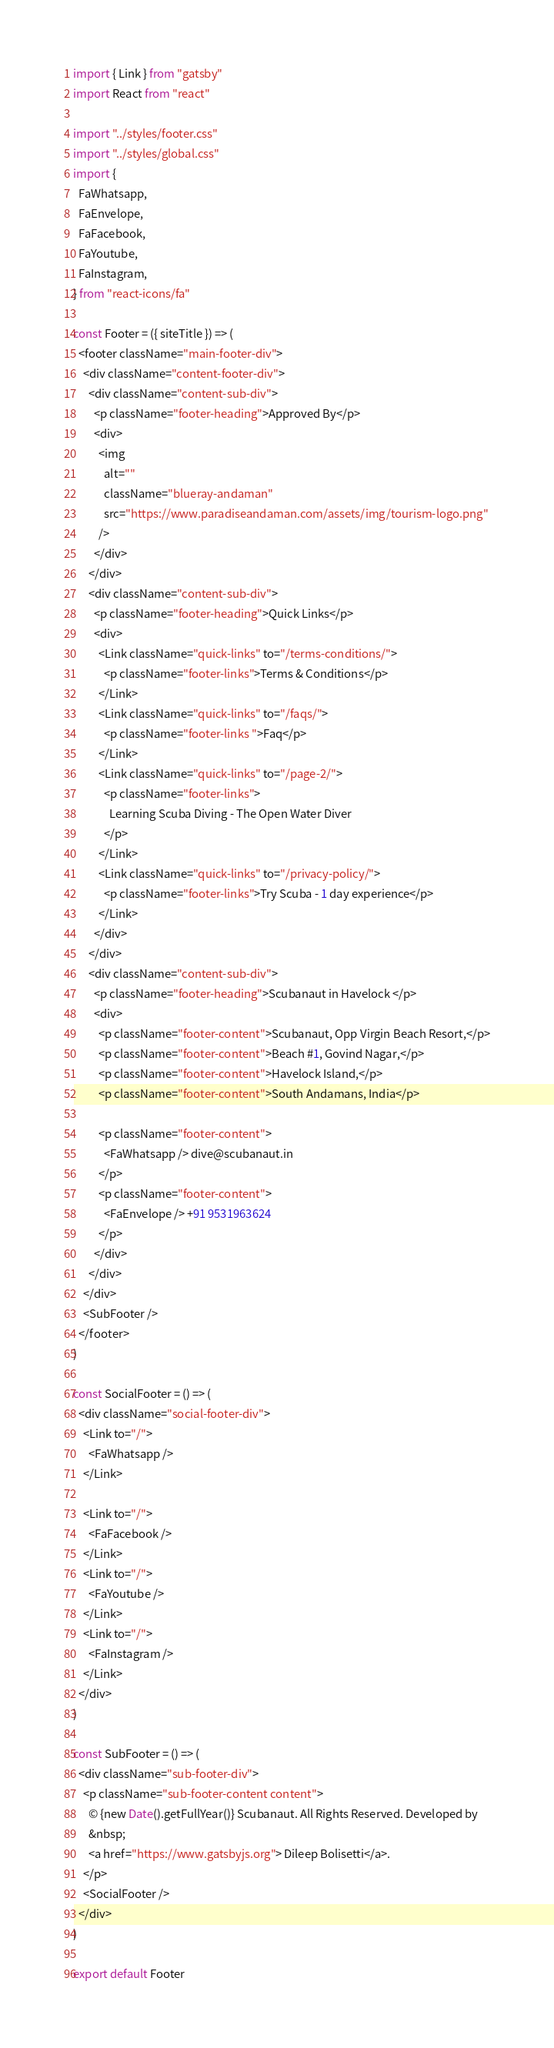<code> <loc_0><loc_0><loc_500><loc_500><_JavaScript_>import { Link } from "gatsby"
import React from "react"

import "../styles/footer.css"
import "../styles/global.css"
import {
  FaWhatsapp,
  FaEnvelope,
  FaFacebook,
  FaYoutube,
  FaInstagram,
} from "react-icons/fa"

const Footer = ({ siteTitle }) => (
  <footer className="main-footer-div">
    <div className="content-footer-div">
      <div className="content-sub-div">
        <p className="footer-heading">Approved By</p>
        <div>
          <img
            alt=""
            className="blueray-andaman"
            src="https://www.paradiseandaman.com/assets/img/tourism-logo.png"
          />
        </div>
      </div>
      <div className="content-sub-div">
        <p className="footer-heading">Quick Links</p>
        <div>
          <Link className="quick-links" to="/terms-conditions/">
            <p className="footer-links">Terms & Conditions</p>
          </Link>
          <Link className="quick-links" to="/faqs/">
            <p className="footer-links ">Faq</p>
          </Link>
          <Link className="quick-links" to="/page-2/">
            <p className="footer-links">
              Learning Scuba Diving - The Open Water Diver
            </p>
          </Link>
          <Link className="quick-links" to="/privacy-policy/">
            <p className="footer-links">Try Scuba - 1 day experience</p>
          </Link>
        </div>
      </div>
      <div className="content-sub-div">
        <p className="footer-heading">Scubanaut in Havelock </p>
        <div>
          <p className="footer-content">Scubanaut, Opp Virgin Beach Resort,</p>
          <p className="footer-content">Beach #1, Govind Nagar,</p>
          <p className="footer-content">Havelock Island,</p>
          <p className="footer-content">South Andamans, India</p>

          <p className="footer-content">
            <FaWhatsapp /> dive@scubanaut.in
          </p>
          <p className="footer-content">
            <FaEnvelope /> +91 9531963624
          </p>
        </div>
      </div>
    </div>
    <SubFooter />
  </footer>
)

const SocialFooter = () => (
  <div className="social-footer-div">
    <Link to="/">
      <FaWhatsapp />
    </Link>

    <Link to="/">
      <FaFacebook />
    </Link>
    <Link to="/">
      <FaYoutube />
    </Link>
    <Link to="/">
      <FaInstagram />
    </Link>
  </div>
)

const SubFooter = () => (
  <div className="sub-footer-div">
    <p className="sub-footer-content content">
      © {new Date().getFullYear()} Scubanaut. All Rights Reserved. Developed by
      &nbsp;
      <a href="https://www.gatsbyjs.org"> Dileep Bolisetti</a>.
    </p>
    <SocialFooter />
  </div>
)

export default Footer
</code> 